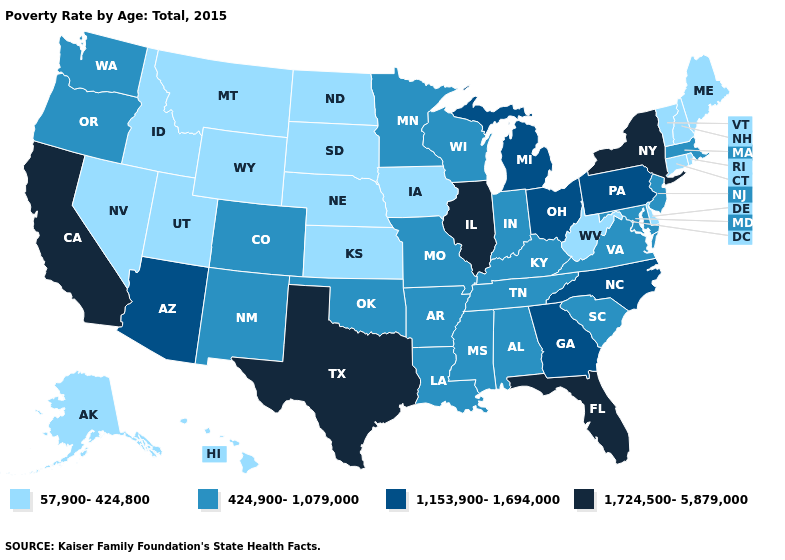What is the highest value in the USA?
Concise answer only. 1,724,500-5,879,000. Does the map have missing data?
Be succinct. No. Name the states that have a value in the range 1,153,900-1,694,000?
Keep it brief. Arizona, Georgia, Michigan, North Carolina, Ohio, Pennsylvania. Name the states that have a value in the range 57,900-424,800?
Short answer required. Alaska, Connecticut, Delaware, Hawaii, Idaho, Iowa, Kansas, Maine, Montana, Nebraska, Nevada, New Hampshire, North Dakota, Rhode Island, South Dakota, Utah, Vermont, West Virginia, Wyoming. Does the first symbol in the legend represent the smallest category?
Give a very brief answer. Yes. What is the highest value in the USA?
Quick response, please. 1,724,500-5,879,000. Does the first symbol in the legend represent the smallest category?
Be succinct. Yes. Name the states that have a value in the range 1,724,500-5,879,000?
Write a very short answer. California, Florida, Illinois, New York, Texas. Does Ohio have the lowest value in the USA?
Short answer required. No. Is the legend a continuous bar?
Short answer required. No. Among the states that border Nevada , does California have the highest value?
Answer briefly. Yes. Does Kansas have the lowest value in the MidWest?
Answer briefly. Yes. Name the states that have a value in the range 57,900-424,800?
Keep it brief. Alaska, Connecticut, Delaware, Hawaii, Idaho, Iowa, Kansas, Maine, Montana, Nebraska, Nevada, New Hampshire, North Dakota, Rhode Island, South Dakota, Utah, Vermont, West Virginia, Wyoming. What is the value of Maryland?
Concise answer only. 424,900-1,079,000. 